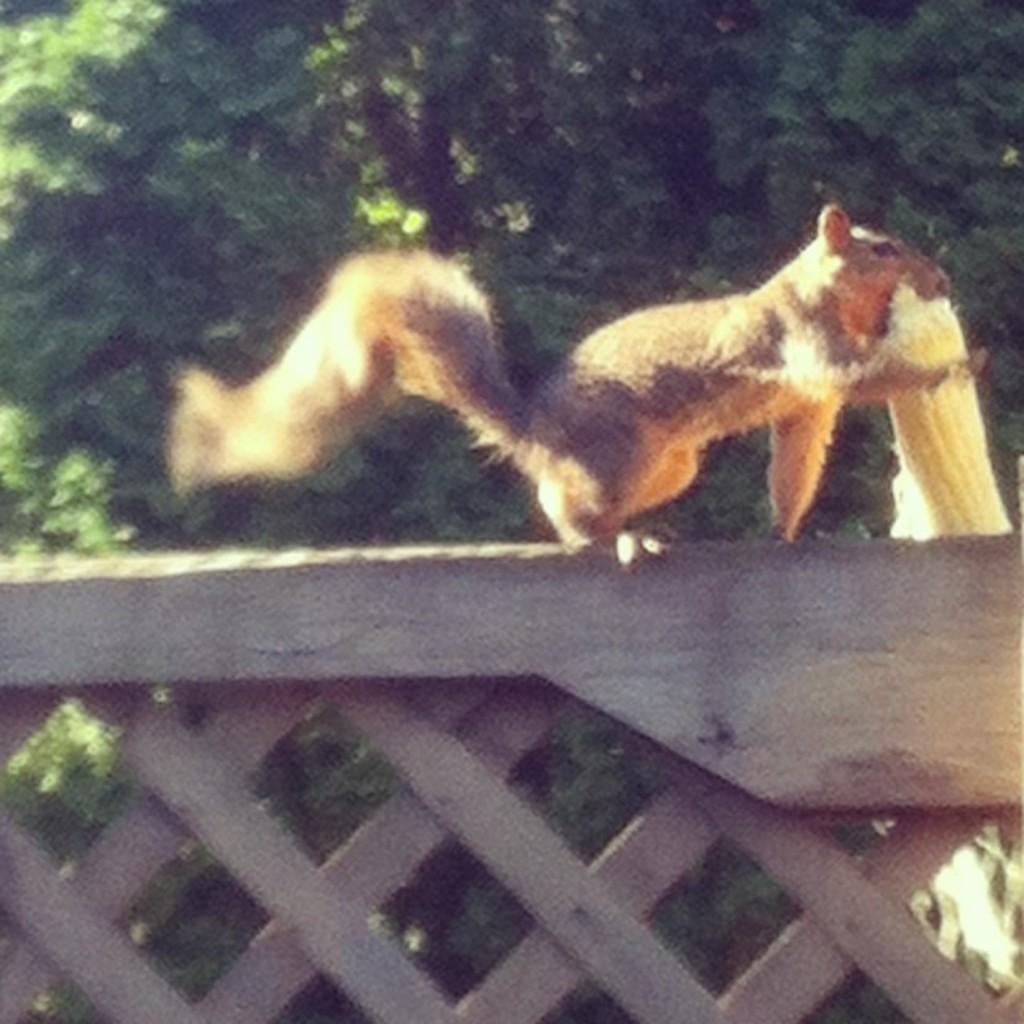What animal can be seen in the image? There is a squirrel on a wooden mesh in the image. What is the squirrel standing on? The squirrel is standing on a wooden mesh. What can be seen in the background of the image? There is a tree in the background of the image. What type of soup is the squirrel holding in the image? There is no soup present in the image; the squirrel is standing on a wooden mesh and there is a tree in the background. 